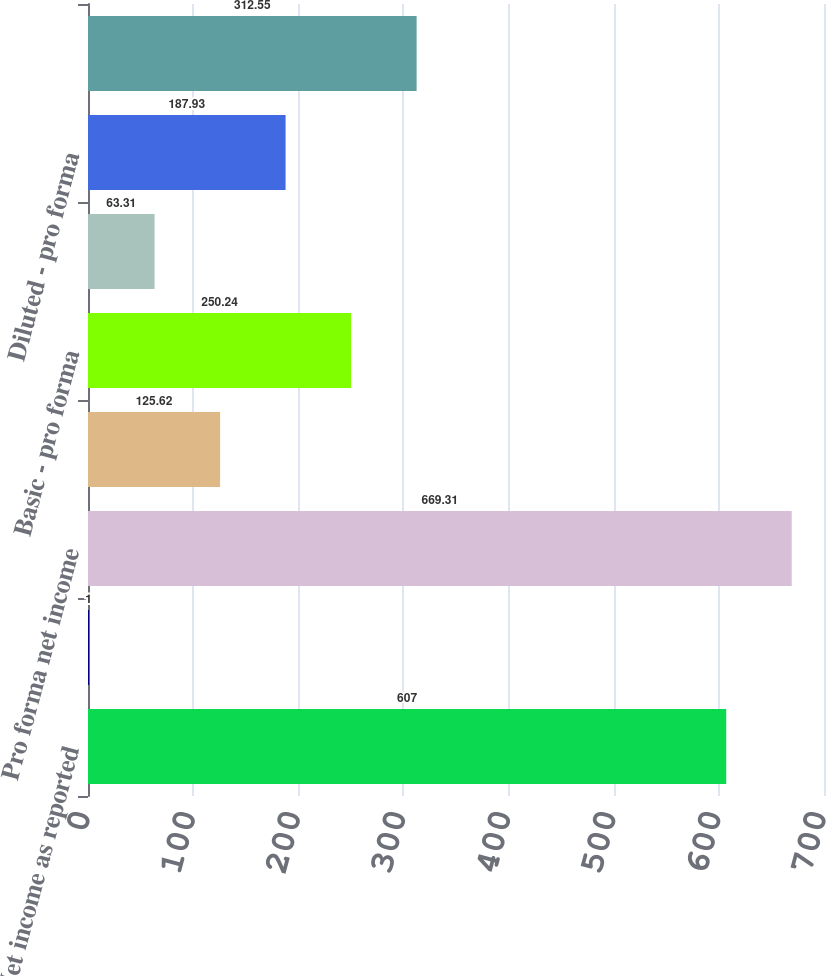<chart> <loc_0><loc_0><loc_500><loc_500><bar_chart><fcel>Net income as reported<fcel>Less FIN 47 depreciation and<fcel>Pro forma net income<fcel>Basic - as reported<fcel>Basic - pro forma<fcel>Diluted - as reported<fcel>Diluted - pro forma<fcel>Pro forma asset retirement<nl><fcel>607<fcel>1<fcel>669.31<fcel>125.62<fcel>250.24<fcel>63.31<fcel>187.93<fcel>312.55<nl></chart> 